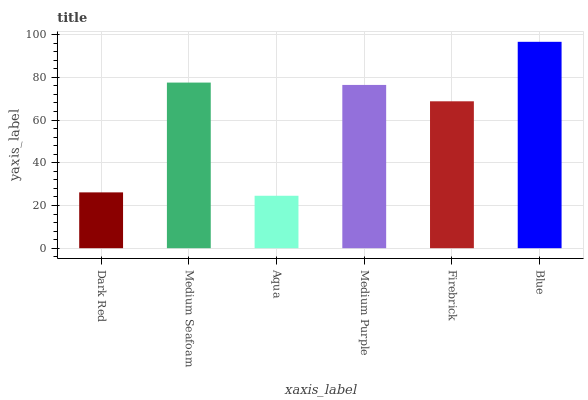Is Medium Seafoam the minimum?
Answer yes or no. No. Is Medium Seafoam the maximum?
Answer yes or no. No. Is Medium Seafoam greater than Dark Red?
Answer yes or no. Yes. Is Dark Red less than Medium Seafoam?
Answer yes or no. Yes. Is Dark Red greater than Medium Seafoam?
Answer yes or no. No. Is Medium Seafoam less than Dark Red?
Answer yes or no. No. Is Medium Purple the high median?
Answer yes or no. Yes. Is Firebrick the low median?
Answer yes or no. Yes. Is Aqua the high median?
Answer yes or no. No. Is Medium Seafoam the low median?
Answer yes or no. No. 